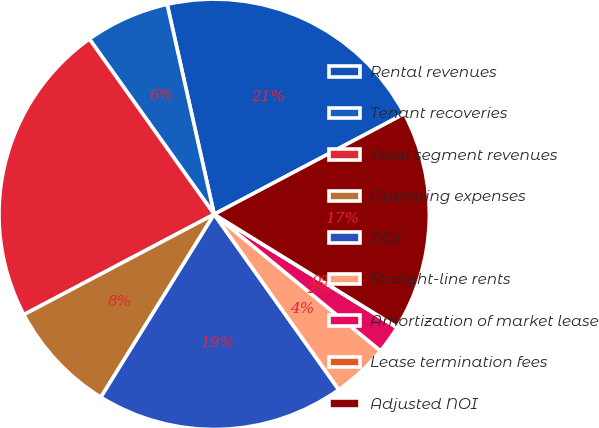Convert chart. <chart><loc_0><loc_0><loc_500><loc_500><pie_chart><fcel>Rental revenues<fcel>Tenant recoveries<fcel>Total segment revenues<fcel>Operating expenses<fcel>NOI<fcel>Straight-line rents<fcel>Amortization of market lease<fcel>Lease termination fees<fcel>Adjusted NOI<nl><fcel>20.76%<fcel>6.34%<fcel>22.87%<fcel>8.45%<fcel>18.65%<fcel>4.23%<fcel>2.12%<fcel>0.01%<fcel>16.54%<nl></chart> 